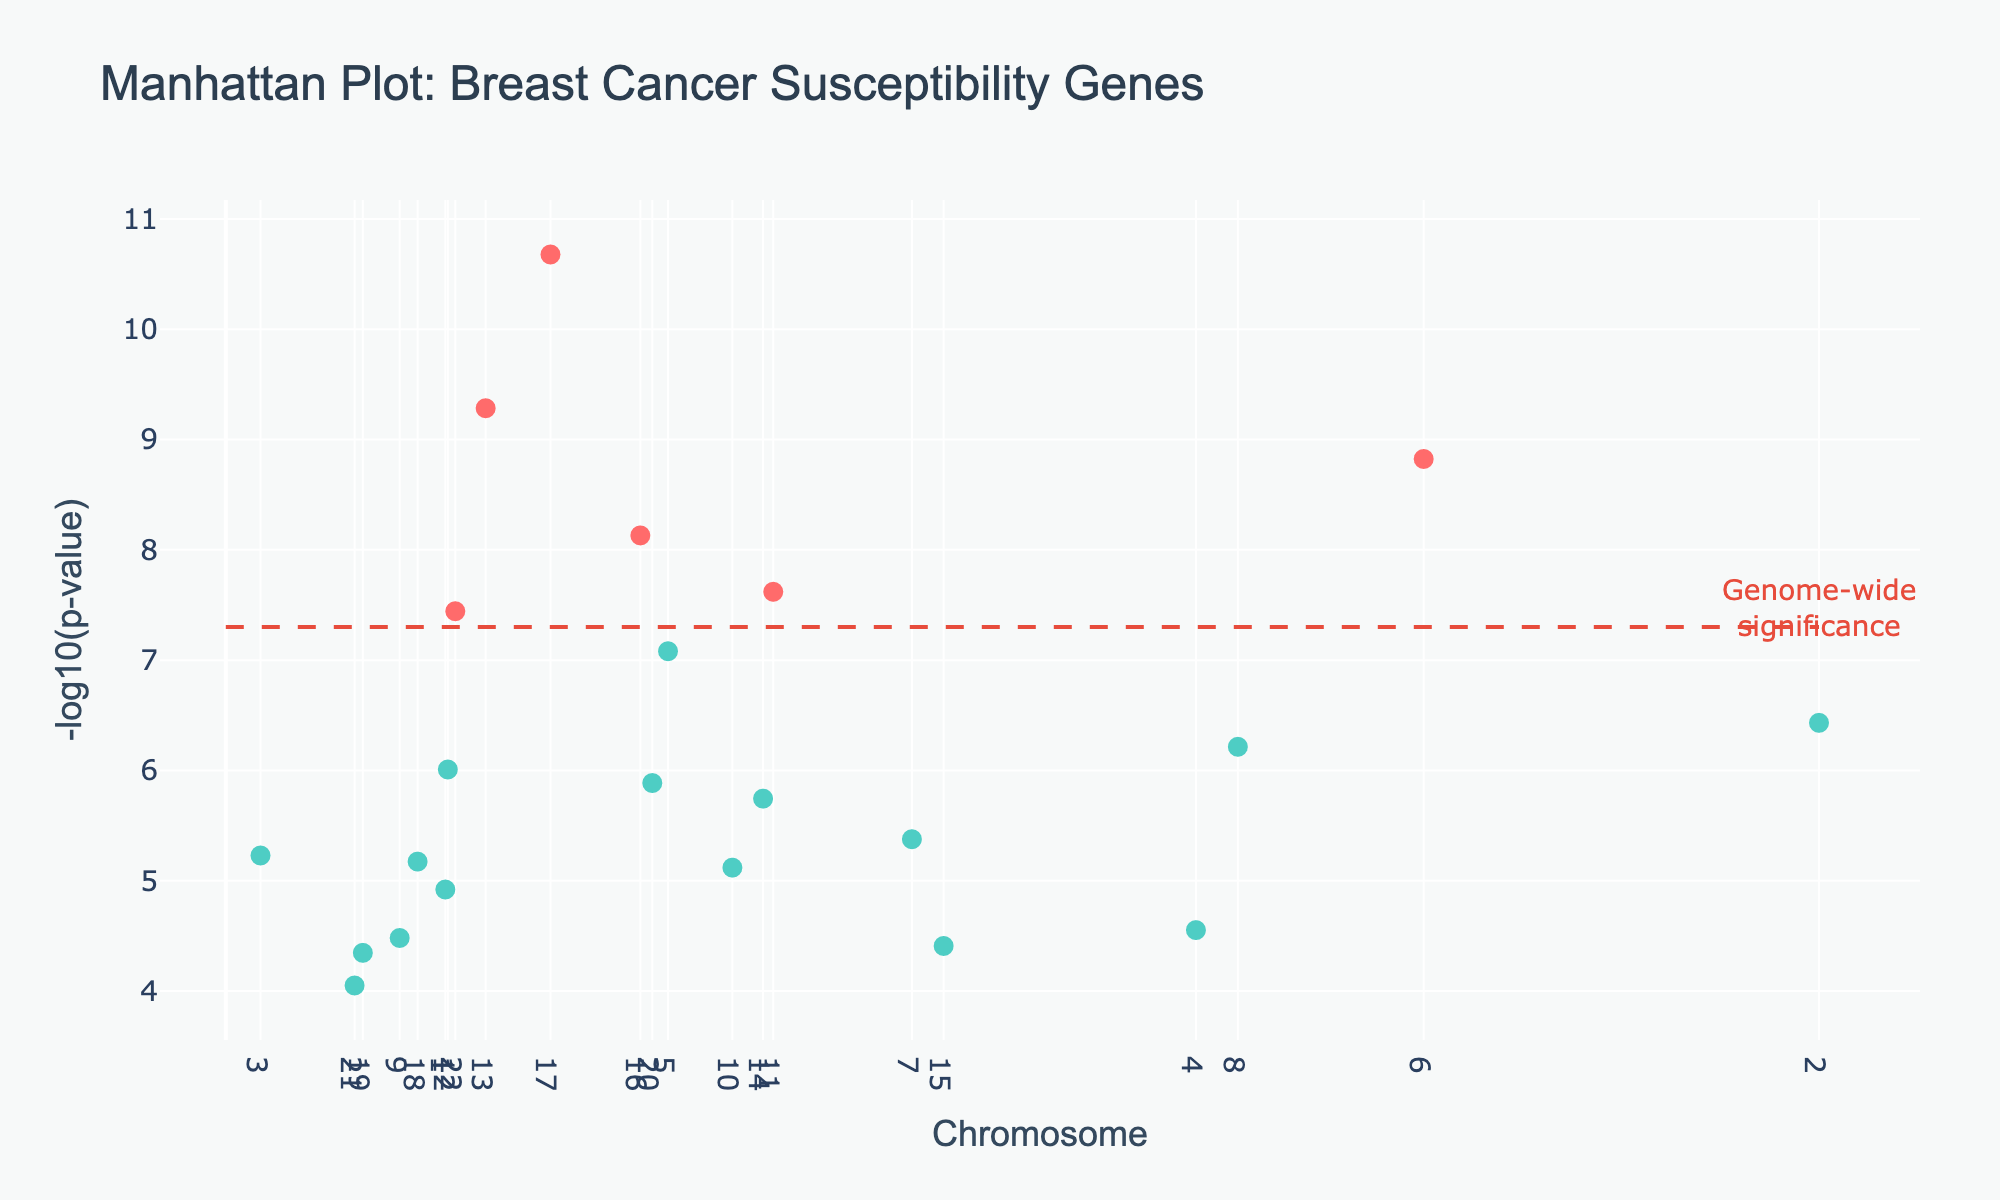Which gene has the smallest p-value? The smallest p-value corresponds to the largest -log10(P_value) on the y-axis. This gene is highest in the plot. Hovering over the plot, BRCA1 on chromosome 17 has the smallest p-value.
Answer: BRCA1 How many genes have a p-value below the genome-wide significance threshold? The genome-wide significance threshold is denoted by the red dashed line at -log10(5e-8). Counting the points above this line, which shows genes with p-values below the threshold, there are seven genes.
Answer: 7 Which chromosome has the highest number of associated genes below the genome-wide significance threshold? Identify the chromosome with the most data points above the red dashed line (indicating p-values below 5e-8). Chromosome 17 has the most genes meeting this criterion.
Answer: Chromosome 17 What is the p-value for the gene ESR1 on chromosome 6? To find the p-value for ESR1, locate chromosome 6 on the x-axis and hover over the data point to see the corresponding p-value. The plot indicates that ESR1 has a p-value of 1.5e-09.
Answer: 1.5e-09 Which genes have a p-value exactly at the genome-wide significance threshold? To find genes at the exact threshold, locate points on the red dashed line at -log10(5e-8). In this dataset, no points are exactly on the line, so there are no genes at the precise threshold.
Answer: None Compare the p-values of BRCA1 and BRCA2; which one is more significant? Check the -log10(p-value) of BRCA1 and BRCA2 by identifying their positions on chromosomes 17 and 13, respectively. BRCA1 has a higher -log10(p-value), indicating a more significant p-value than BRCA2.
Answer: BRCA1 Which chromosome has the gene with the most significant association with breast cancer susceptibility? The gene with the highest -log10(p-value) is the most significant. Identifying this point, we find BRCA1 on chromosome 17 is the most significant gene.
Answer: Chromosome 17 What is the p-value for the least significant gene displayed in the plot? The least significant gene will have the lowest -log10(p-value) and appear lowest on the y-axis. Hovering over the lowest point, NRIP1 on chromosome 21 has the highest p-value of 8.9e-05.
Answer: 8.9e-05 